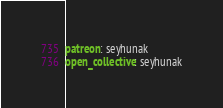<code> <loc_0><loc_0><loc_500><loc_500><_YAML_>
patreon: seyhunak
open_collective: seyhunak
</code> 